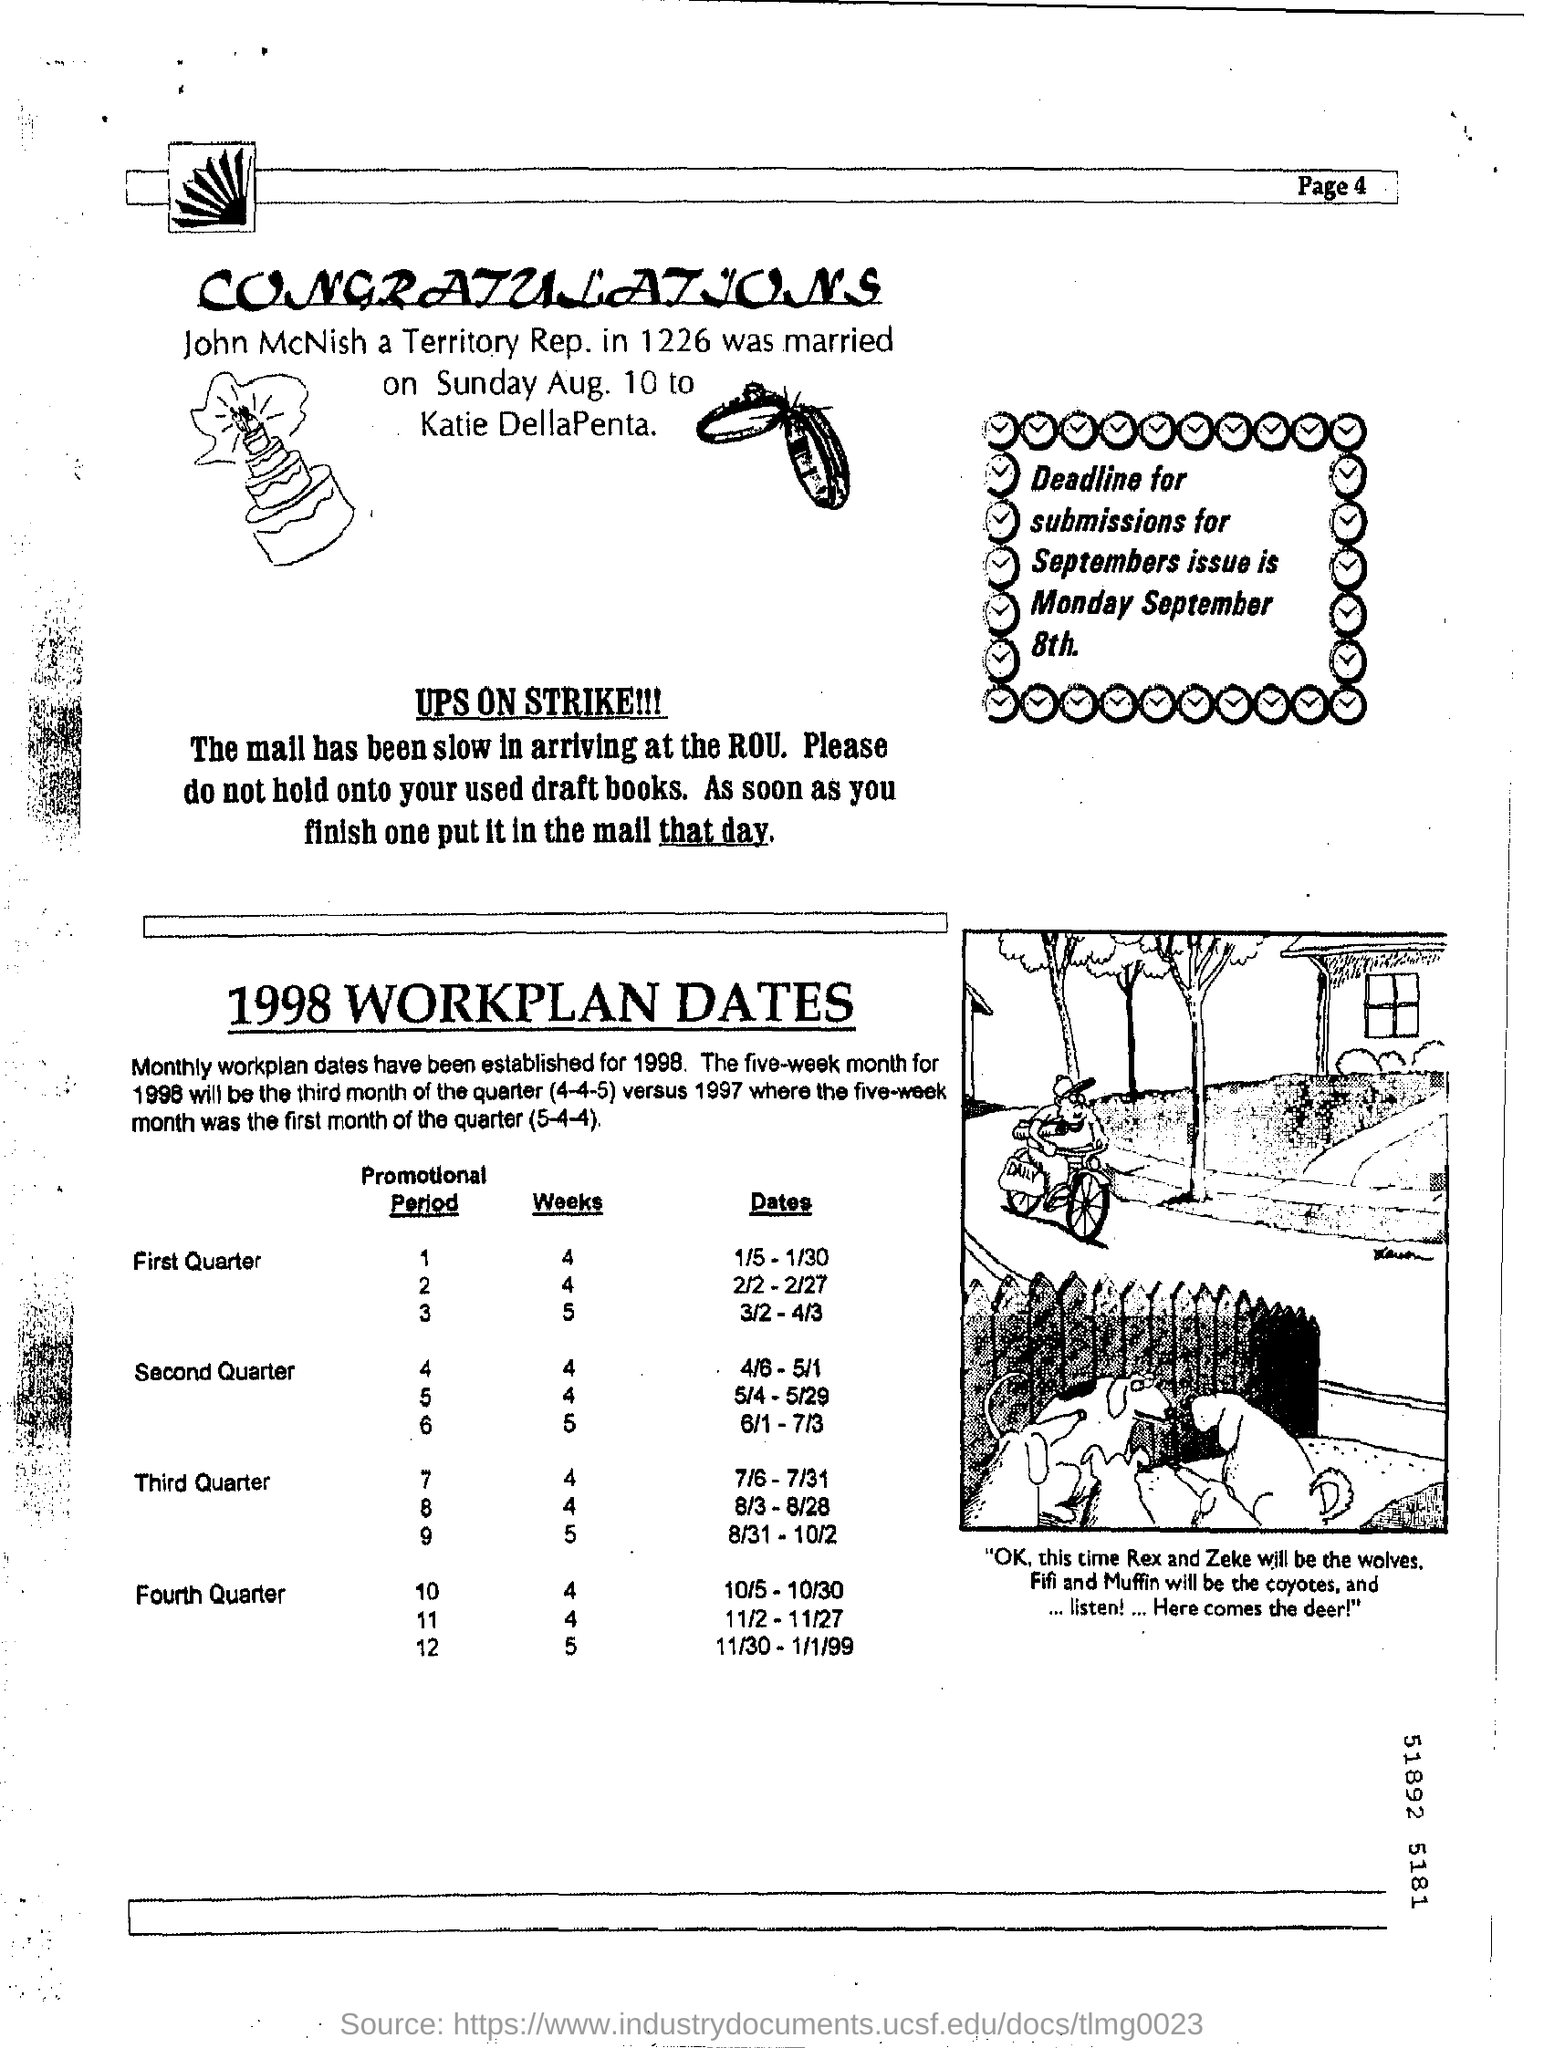Highlight a few significant elements in this photo. The deadline for submissions for the September issue is Monday, September 8th. To whom is John McNish married to? His wife is Katie DellaPenta. John McNish is a territory representative who is being questioned by authorities for unknown reasons. The page number mentioned in this document is 4.. 